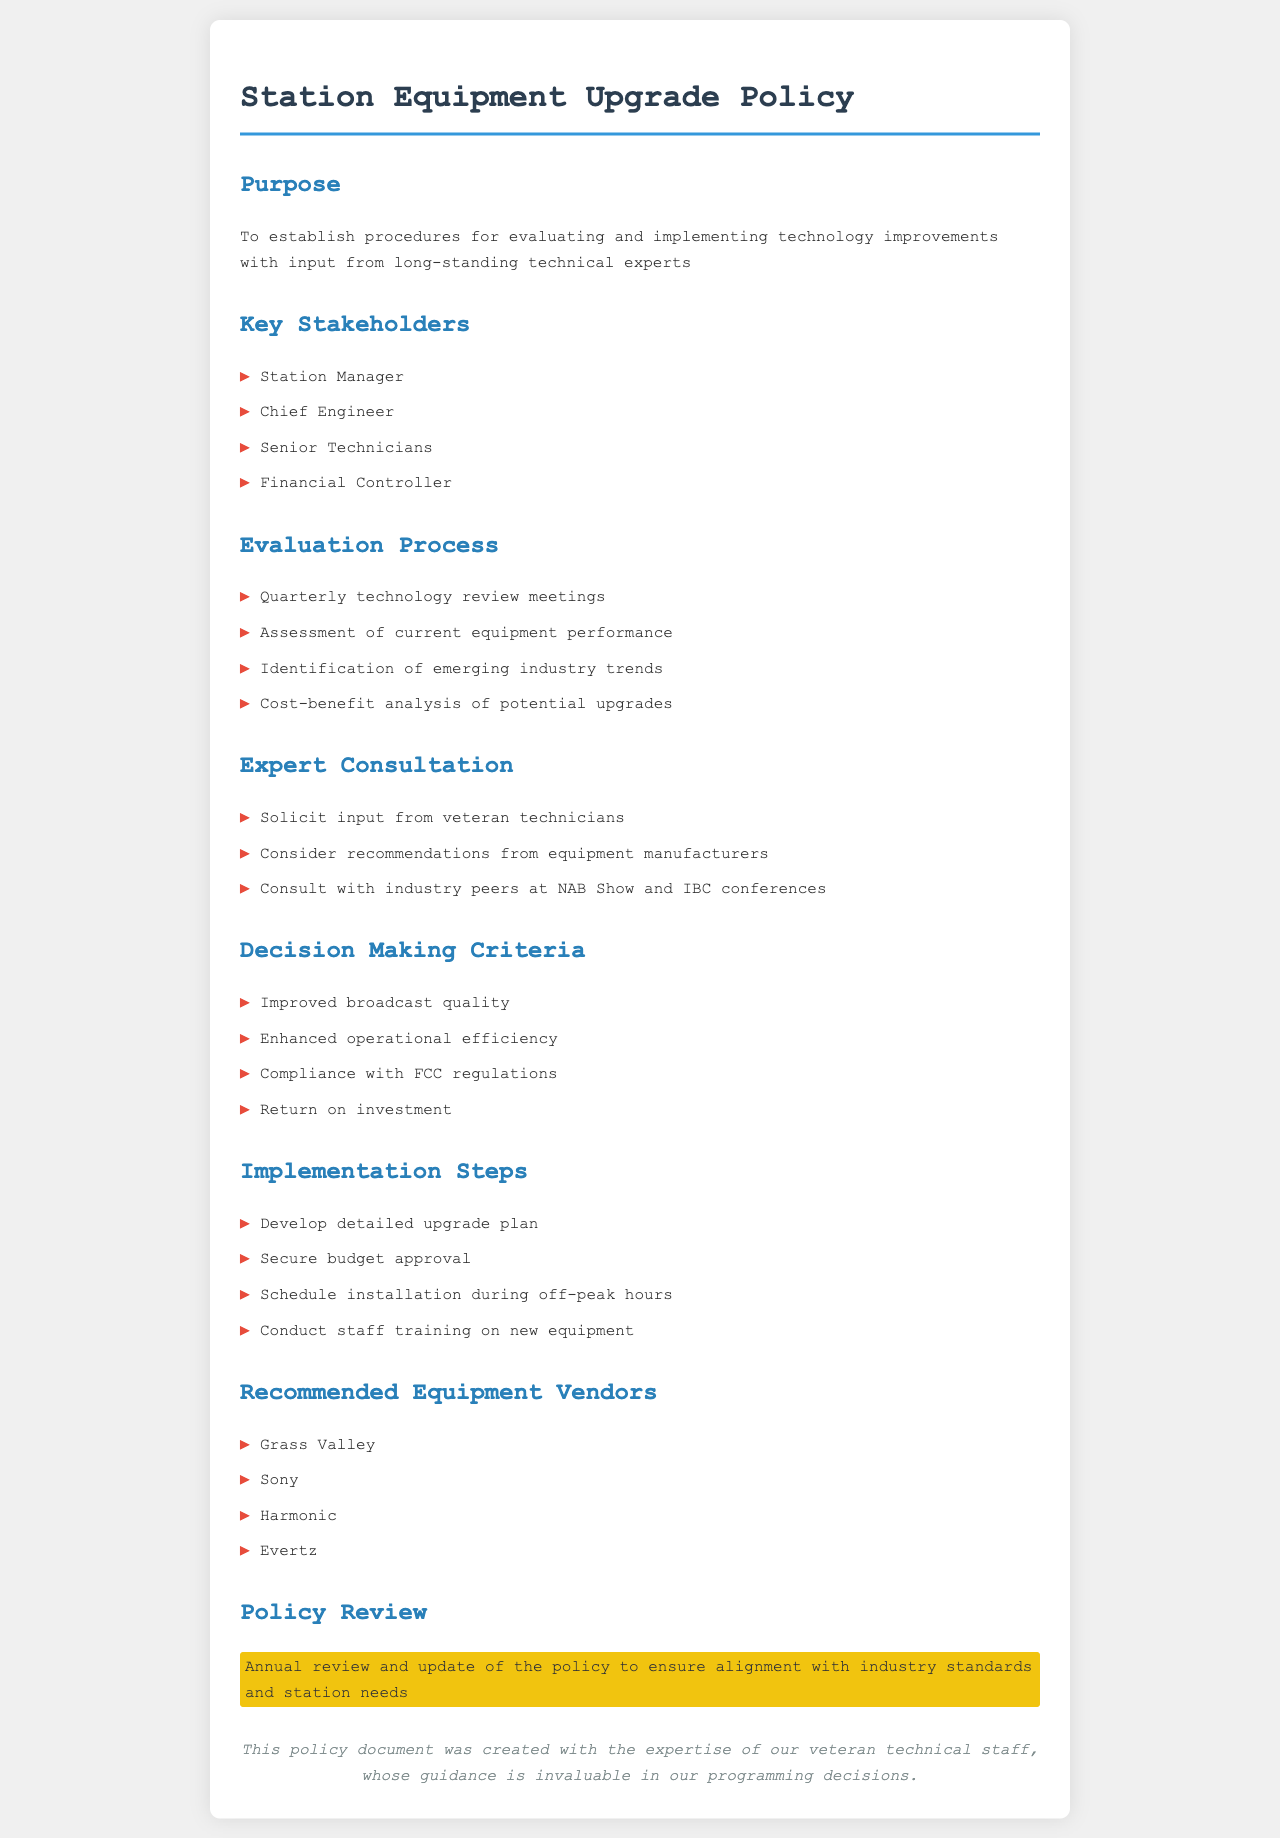What is the purpose of the policy? The purpose is aimed at establishing procedures for evaluating and implementing technology improvements with input from long-standing technical experts.
Answer: Evaluating and implementing technology improvements Who are the key stakeholders? The key stakeholders are listed in the document and include those involved in the upgrade process.
Answer: Station Manager, Chief Engineer, Senior Technicians, Financial Controller How often are technology review meetings held? The document specifies the frequency of these meetings as part of the evaluation process.
Answer: Quarterly What criteria is used for decision making? The document outlines specific criteria used for making decisions about upgrades.
Answer: Improved broadcast quality, Enhanced operational efficiency, Compliance with FCC regulations, Return on investment What vendors are recommended for equipment? The document lists specific vendors that are recommended for purchasing equipment upgrades.
Answer: Grass Valley, Sony, Harmonic, Evertz How is staff prepared for new equipment? The implementation steps in the document include the process for staff preparation regarding new equipment.
Answer: Conduct staff training on new equipment What is highlighted in the policy review section? The policy review section emphasizes the frequency and purpose of reviewing the policy.
Answer: Annual review and update of the policy Who provides valuable guidance in programming decisions? The document mentions who contributes invaluable guidance for decision-making processes in the station.
Answer: Veteran technical staff 